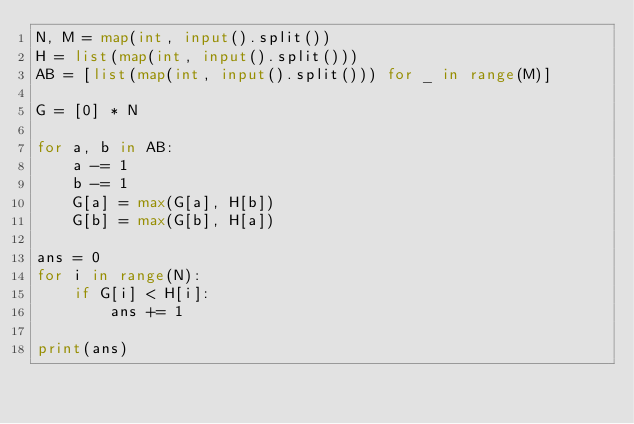<code> <loc_0><loc_0><loc_500><loc_500><_Python_>N, M = map(int, input().split())
H = list(map(int, input().split()))
AB = [list(map(int, input().split())) for _ in range(M)]

G = [0] * N

for a, b in AB:
    a -= 1
    b -= 1
    G[a] = max(G[a], H[b])
    G[b] = max(G[b], H[a])

ans = 0
for i in range(N):
    if G[i] < H[i]:
        ans += 1

print(ans)</code> 